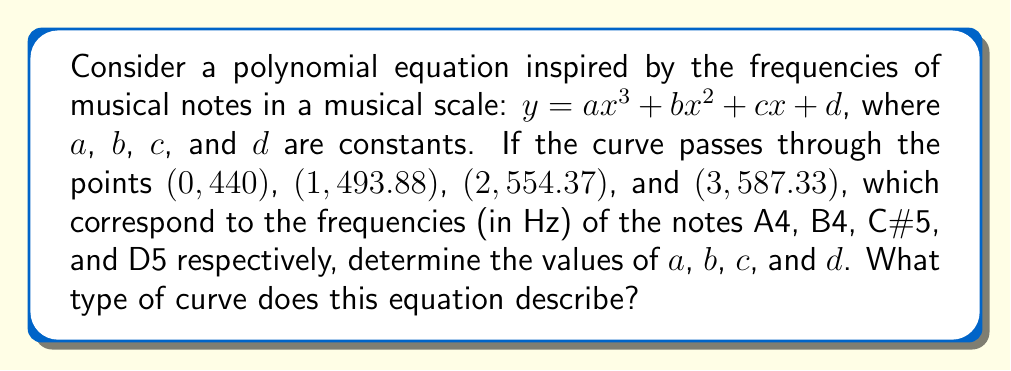Could you help me with this problem? Let's approach this step-by-step:

1) We have four points that the curve passes through:
   $(0, 440)$, $(1, 493.88)$, $(2, 554.37)$, and $(3, 587.33)$

2) Substituting these points into the equation $y = ax^3 + bx^2 + cx + d$:

   $440 = a(0)^3 + b(0)^2 + c(0) + d$
   $493.88 = a(1)^3 + b(1)^2 + c(1) + d$
   $554.37 = a(2)^3 + b(2)^2 + c(2) + d$
   $587.33 = a(3)^3 + b(3)^2 + c(3) + d$

3) Simplifying:

   $440 = d$
   $493.88 = a + b + c + 440$
   $554.37 = 8a + 4b + 2c + 440$
   $587.33 = 27a + 9b + 3c + 440$

4) Subtracting 440 from each equation:

   $0 = 0$
   $53.88 = a + b + c$
   $114.37 = 8a + 4b + 2c$
   $147.33 = 27a + 9b + 3c$

5) Now we have a system of three equations with three unknowns. We can solve this using substitution or matrix methods. After solving:

   $a = -5.385$
   $b = 71.565$
   $c = -12.3$
   $d = 440$

6) Therefore, the equation of the curve is:

   $y = -5.385x^3 + 71.565x^2 - 12.3x + 440$

7) This equation describes a cubic curve. Specifically, it's a type of polynomial curve of degree 3.
Answer: Cubic curve: $y = -5.385x^3 + 71.565x^2 - 12.3x + 440$ 